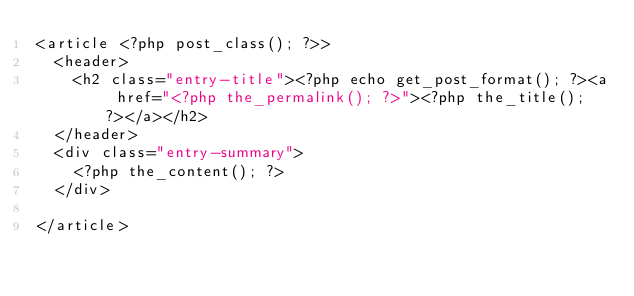Convert code to text. <code><loc_0><loc_0><loc_500><loc_500><_PHP_><article <?php post_class(); ?>>
	<header>
		<h2 class="entry-title"><?php echo get_post_format(); ?><a href="<?php the_permalink(); ?>"><?php the_title(); ?></a></h2>
	</header>
	<div class="entry-summary">
		<?php the_content(); ?>
	</div>

</article>
</code> 